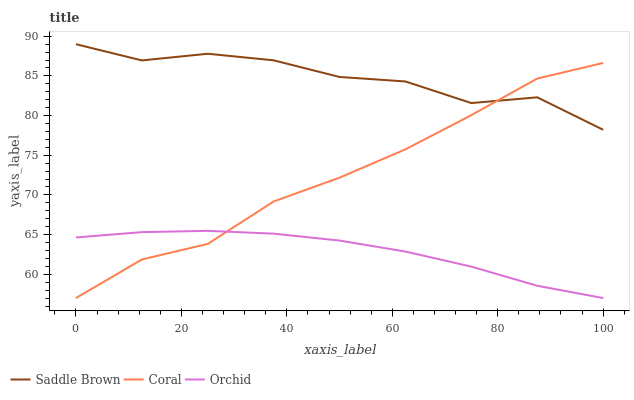Does Orchid have the minimum area under the curve?
Answer yes or no. Yes. Does Saddle Brown have the maximum area under the curve?
Answer yes or no. Yes. Does Saddle Brown have the minimum area under the curve?
Answer yes or no. No. Does Orchid have the maximum area under the curve?
Answer yes or no. No. Is Orchid the smoothest?
Answer yes or no. Yes. Is Saddle Brown the roughest?
Answer yes or no. Yes. Is Saddle Brown the smoothest?
Answer yes or no. No. Is Orchid the roughest?
Answer yes or no. No. Does Coral have the lowest value?
Answer yes or no. Yes. Does Saddle Brown have the lowest value?
Answer yes or no. No. Does Saddle Brown have the highest value?
Answer yes or no. Yes. Does Orchid have the highest value?
Answer yes or no. No. Is Orchid less than Saddle Brown?
Answer yes or no. Yes. Is Saddle Brown greater than Orchid?
Answer yes or no. Yes. Does Coral intersect Orchid?
Answer yes or no. Yes. Is Coral less than Orchid?
Answer yes or no. No. Is Coral greater than Orchid?
Answer yes or no. No. Does Orchid intersect Saddle Brown?
Answer yes or no. No. 